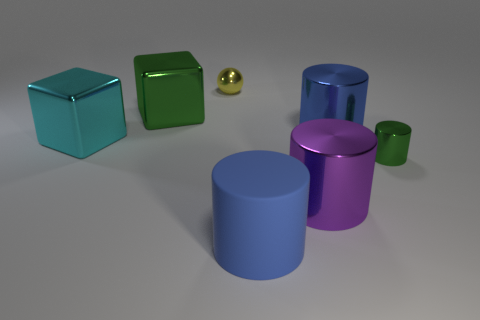There is a cube that is the same color as the small shiny cylinder; what is its material?
Give a very brief answer. Metal. There is a metallic block to the left of the large green shiny block; what color is it?
Provide a short and direct response. Cyan. Are there any cyan metallic cubes that are right of the cube in front of the big blue metallic object?
Give a very brief answer. No. How many other objects are the same color as the big rubber cylinder?
Provide a succinct answer. 1. Is the size of the metallic cylinder that is behind the green metallic cylinder the same as the green object that is to the left of the big purple metallic object?
Your answer should be compact. Yes. There is a object that is behind the green thing left of the small shiny ball; what size is it?
Provide a short and direct response. Small. The large thing that is behind the large purple cylinder and to the right of the shiny ball is made of what material?
Keep it short and to the point. Metal. What is the color of the small shiny ball?
Your answer should be very brief. Yellow. Is there any other thing that has the same material as the tiny yellow object?
Give a very brief answer. Yes. The small metallic thing that is on the right side of the tiny metal sphere has what shape?
Provide a short and direct response. Cylinder. 